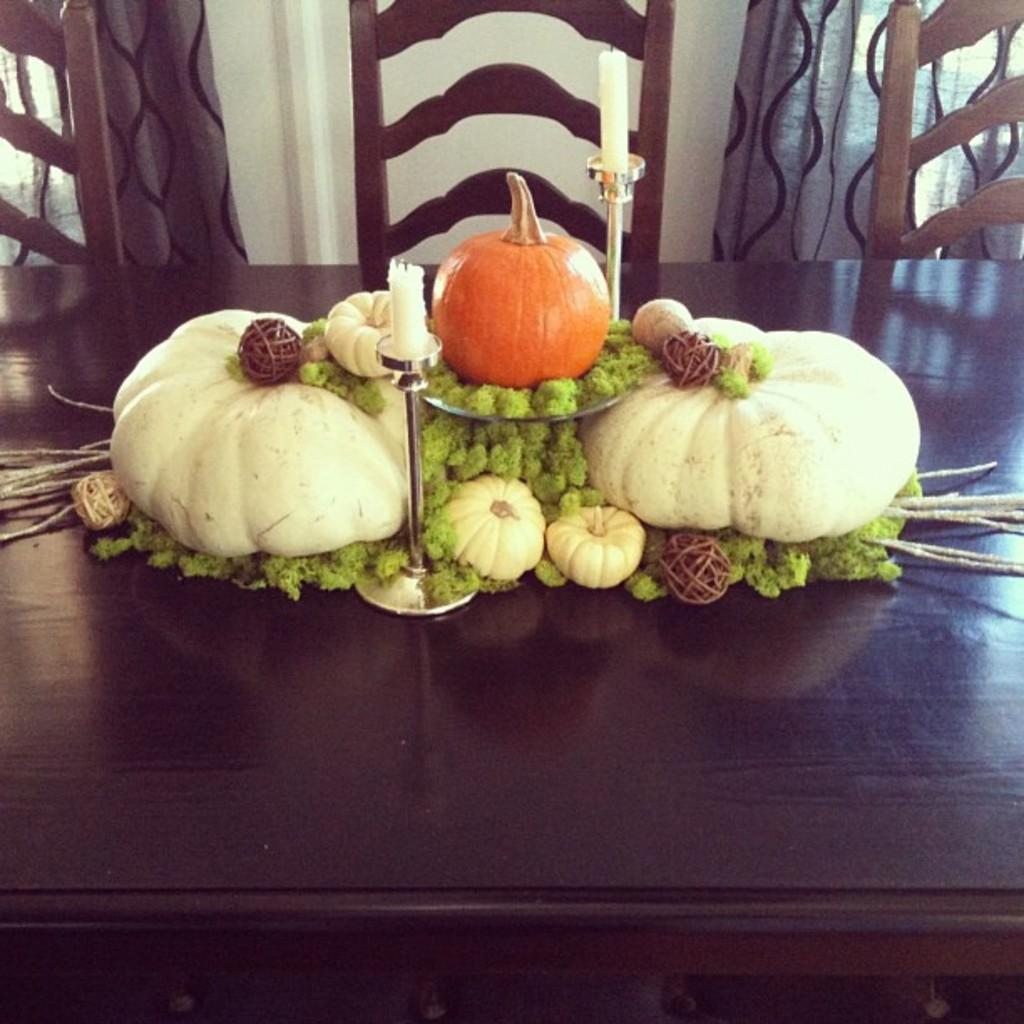What type of objects are on the table in the image? There are pumpkins and candles on the table in the image. How many candles are on the table? There are 2 candles on the table. What are the candle stands used for? The candle stands are used to hold the candles on the table. What colors are associated with the pumpkins? The pumpkins have green and brown colors. How many chairs are visible behind the table? There are 3 chairs behind the table. What can be seen in the background of the image? There are curtains visible in the image. What type of treatment is being administered to the monkey in the image? There is no monkey present in the image, and therefore no treatment is being administered. 